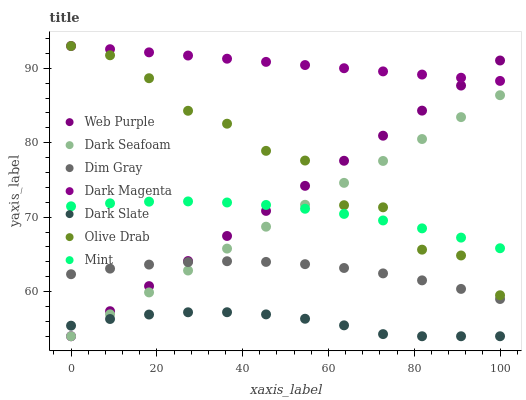Does Dark Slate have the minimum area under the curve?
Answer yes or no. Yes. Does Dark Magenta have the maximum area under the curve?
Answer yes or no. Yes. Does Dark Seafoam have the minimum area under the curve?
Answer yes or no. No. Does Dark Seafoam have the maximum area under the curve?
Answer yes or no. No. Is Dark Magenta the smoothest?
Answer yes or no. Yes. Is Olive Drab the roughest?
Answer yes or no. Yes. Is Dark Seafoam the smoothest?
Answer yes or no. No. Is Dark Seafoam the roughest?
Answer yes or no. No. Does Dark Seafoam have the lowest value?
Answer yes or no. Yes. Does Dark Magenta have the lowest value?
Answer yes or no. No. Does Olive Drab have the highest value?
Answer yes or no. Yes. Does Dark Seafoam have the highest value?
Answer yes or no. No. Is Dark Slate less than Mint?
Answer yes or no. Yes. Is Dim Gray greater than Dark Slate?
Answer yes or no. Yes. Does Dark Seafoam intersect Olive Drab?
Answer yes or no. Yes. Is Dark Seafoam less than Olive Drab?
Answer yes or no. No. Is Dark Seafoam greater than Olive Drab?
Answer yes or no. No. Does Dark Slate intersect Mint?
Answer yes or no. No. 